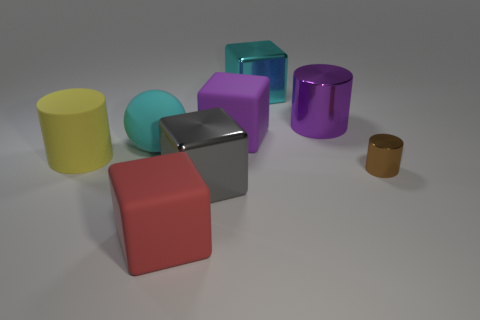What color is the other rubber object that is the same shape as the brown thing?
Make the answer very short. Yellow. Are there any other things of the same color as the small thing?
Offer a very short reply. No. Does the purple cylinder have the same material as the large red cube?
Give a very brief answer. No. Are there fewer big red metallic things than big cyan cubes?
Your answer should be very brief. Yes. Does the yellow matte object have the same shape as the big purple matte object?
Your answer should be compact. No. What is the color of the large rubber cylinder?
Offer a terse response. Yellow. What number of other things are there of the same material as the cyan block
Ensure brevity in your answer.  3. How many red things are either rubber blocks or large balls?
Your response must be concise. 1. Is the shape of the rubber thing that is in front of the small shiny cylinder the same as the large metallic thing in front of the tiny brown metallic cylinder?
Offer a terse response. Yes. There is a large matte cylinder; is its color the same as the shiny cube on the right side of the big gray block?
Your answer should be very brief. No. 